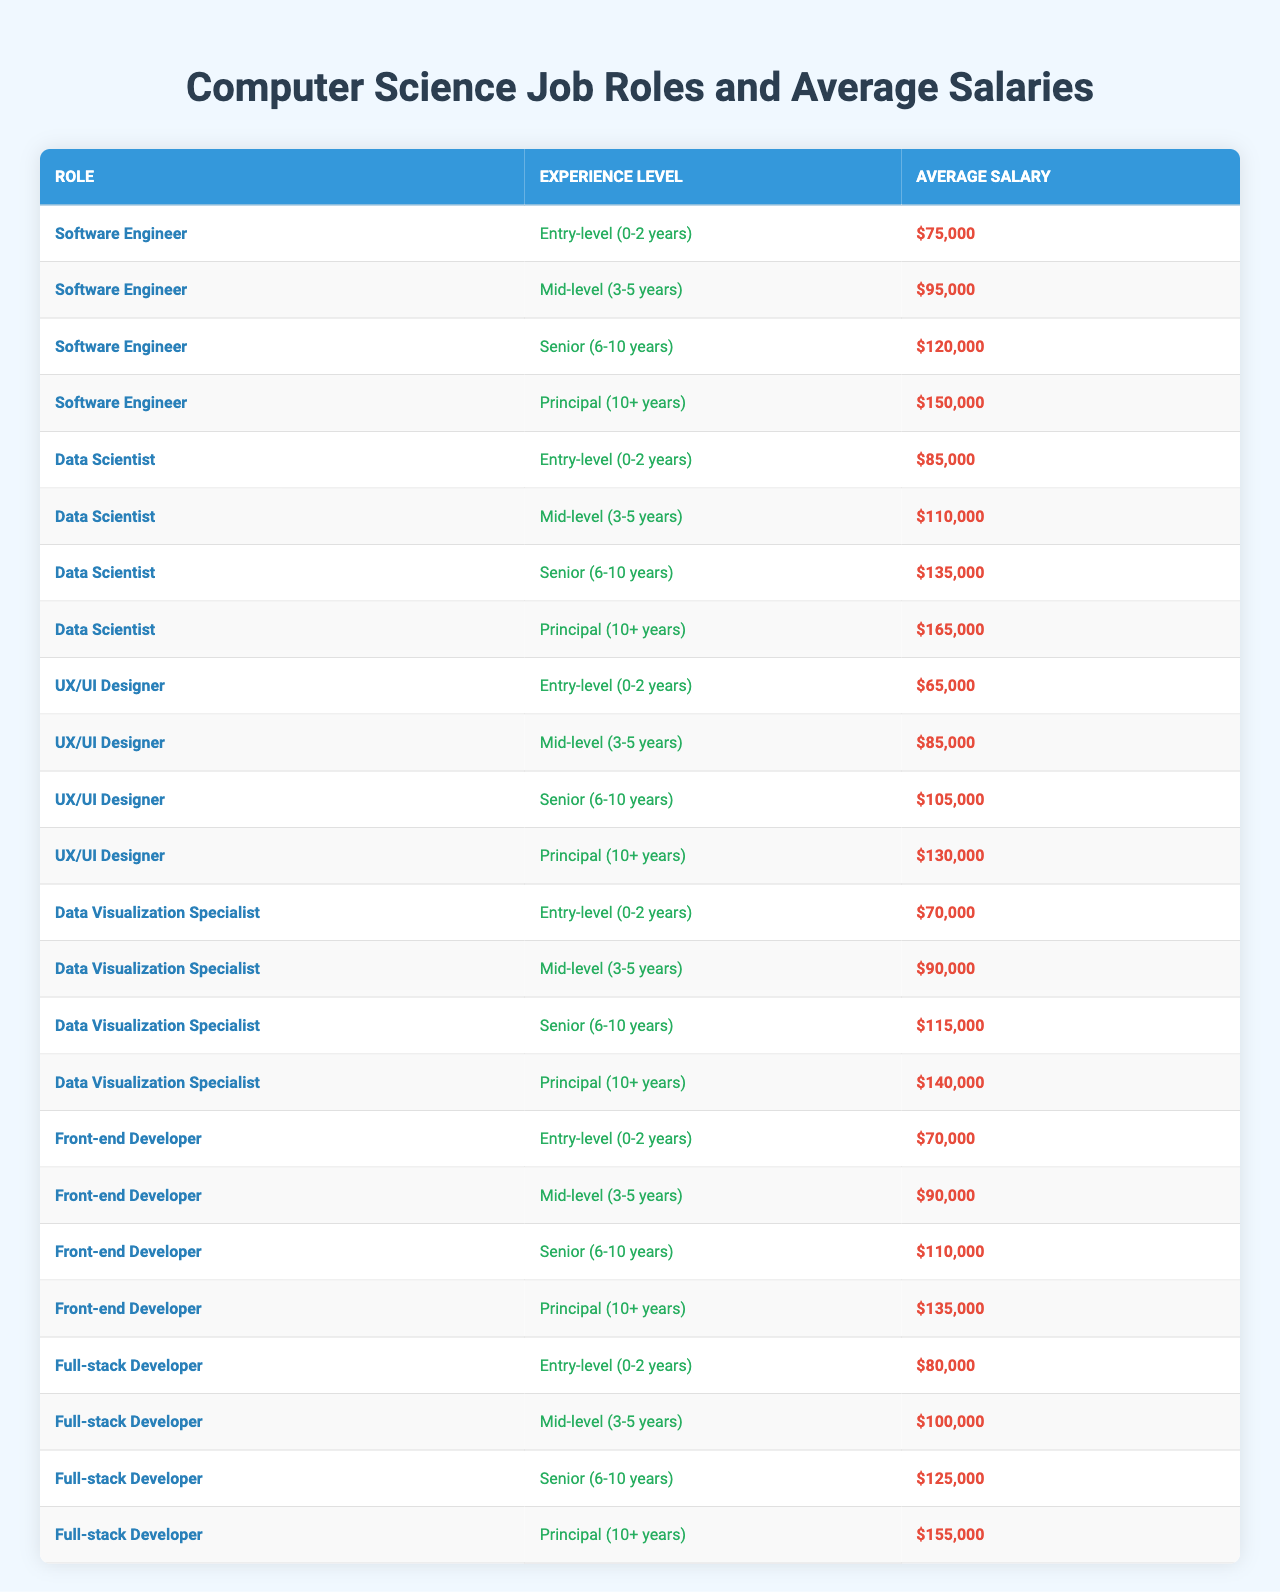What is the average salary for an Entry-level Software Engineer? The table shows that the average salary for an Entry-level Software Engineer is listed directly under the corresponding row, which is $75,000.
Answer: $75,000 Which role has the highest average salary for Senior level? The Senior level average salaries for all roles are compared: Software Engineer ($120,000), Data Scientist ($135,000), UX/UI Designer ($105,000), Data Visualization Specialist ($115,000), Front-end Developer ($110,000), and Full-stack Developer ($125,000). The Data Scientist has the highest salary at $135,000.
Answer: Data Scientist What is the average salary difference between Mid-level Data Scientist and Mid-level Full-stack Developer? The Mid-level average salary for a Data Scientist is $110,000 and for a Full-stack Developer is $100,000. The difference is calculated as $110,000 - $100,000 = $10,000.
Answer: $10,000 True or False: An Entry-level UX/UI Designer earns more than a Mid-level Data Visualization Specialist. The average salary for an Entry-level UX/UI Designer is $65,000, while the Mid-level Data Visualization Specialist earns $90,000. Since $65,000 is less than $90,000, the statement is false.
Answer: False What is the average salary for Principal level compared among all roles? The Principal level average salaries are as follows: Software Engineer ($150,000), Data Scientist ($165,000), UX/UI Designer ($130,000), Data Visualization Specialist ($140,000), Front-end Developer ($135,000), and Full-stack Developer ($155,000). To find the average, add these values: $150,000 + $165,000 + $130,000 + $140,000 + $135,000 + $155,000 = $975,000. There are 6 roles, so the average is $975,000 / 6 = $162,500.
Answer: $162,500 Which role has the lowest average salary for Mid-level? The Mid-level salaries are: Software Engineer ($95,000), Data Scientist ($110,000), UX/UI Designer ($85,000), Data Visualization Specialist ($90,000), Front-end Developer ($90,000), Full-stack Developer ($100,000). The lowest is for UX/UI Designer at $85,000.
Answer: UX/UI Designer How does the average salary for a Senior Data Visualization Specialist compare to a Senior Software Engineer? The Senior Data Visualization Specialist earns $115,000 while the Senior Software Engineer earns $120,000. The comparison shows that the Senior Software Engineer earns $5,000 more than the Senior Data Visualization Specialist.
Answer: $5,000 more What is the total average salary for all the roles at Entry-level? The Entry-level salaries are: Software Engineer ($75,000), Data Scientist ($85,000), UX/UI Designer ($65,000), Data Visualization Specialist ($70,000), Front-end Developer ($70,000), Full-stack Developer ($80,000). The total is $75,000 + $85,000 + $65,000 + $70,000 + $70,000 + $80,000 = $445,000. To find the average: $445,000 / 6 = $74,166.67.
Answer: $74,166.67 For which levels do the Full-stack Developer and Front-end Developer have the same average salary? Both Full-stack Developer and Front-end Developer have the same average salary at Mid-level ($90,000). This can be identified by observing their salaries side by side at the Mid-level.
Answer: Mid-level Which role sees the largest percentage increase in average salary from Entry-level to Principal level? The formula for percentage increase is: [(Principal Salary - Entry Salary) / Entry Salary] * 100. For Software Engineer: [(150,000 - 75,000) / 75,000] * 100 = 100%. For Data Scientist: [(165,000 - 85,000) / 85,000] * 100 = 94.12%. Continuing this for all, the Software Engineer has the largest percentage increase at 100%.
Answer: Software Engineer 